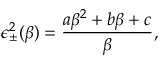<formula> <loc_0><loc_0><loc_500><loc_500>\epsilon _ { \pm } ^ { 2 } ( \beta ) = \frac { a \beta ^ { 2 } + b \beta + c } { \beta } ,</formula> 